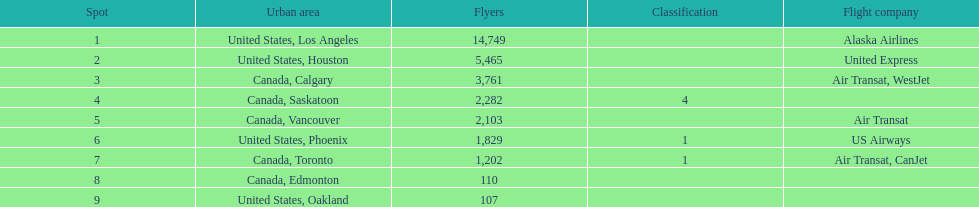How many cities from canada are on this list? 5. 